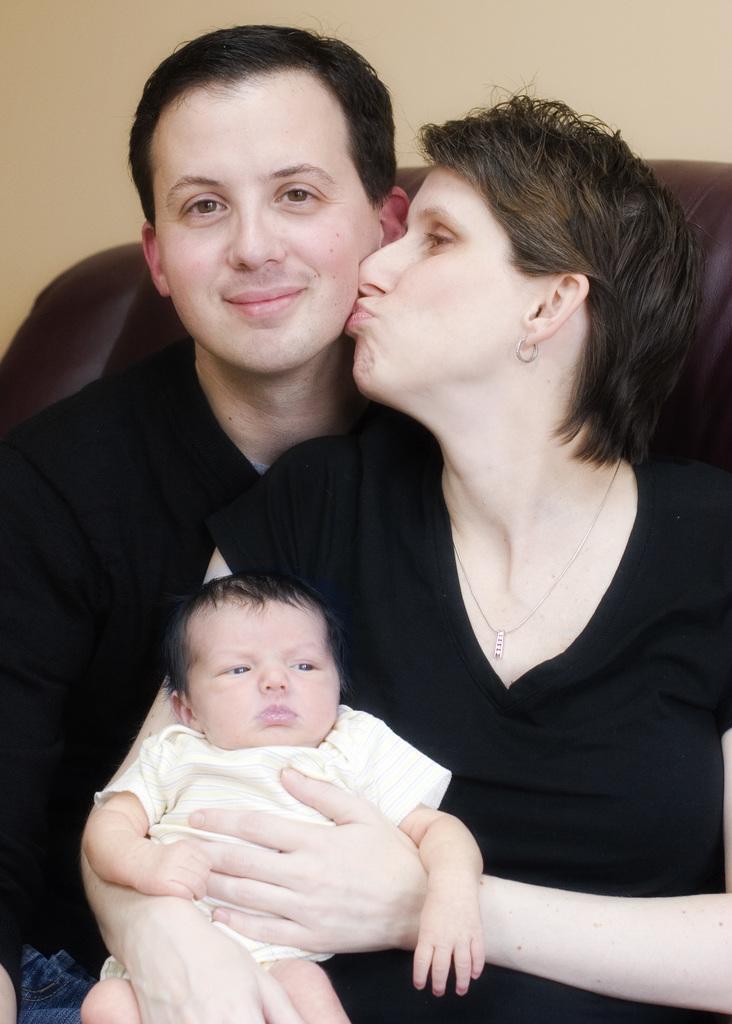Could you give a brief overview of what you see in this image? There two people sitting and she is holding a baby. Background we can see wall. 